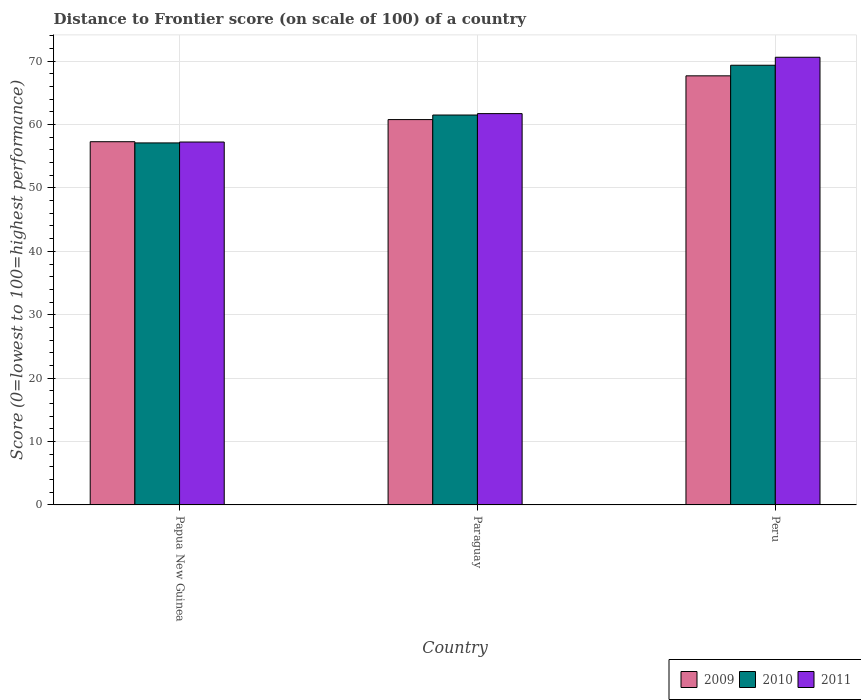Are the number of bars on each tick of the X-axis equal?
Provide a succinct answer. Yes. How many bars are there on the 2nd tick from the left?
Offer a very short reply. 3. What is the label of the 3rd group of bars from the left?
Your answer should be very brief. Peru. What is the distance to frontier score of in 2011 in Paraguay?
Give a very brief answer. 61.72. Across all countries, what is the maximum distance to frontier score of in 2009?
Make the answer very short. 67.68. Across all countries, what is the minimum distance to frontier score of in 2010?
Offer a very short reply. 57.1. In which country was the distance to frontier score of in 2010 maximum?
Your response must be concise. Peru. In which country was the distance to frontier score of in 2009 minimum?
Give a very brief answer. Papua New Guinea. What is the total distance to frontier score of in 2009 in the graph?
Your answer should be very brief. 185.75. What is the difference between the distance to frontier score of in 2010 in Papua New Guinea and that in Paraguay?
Keep it short and to the point. -4.4. What is the difference between the distance to frontier score of in 2011 in Papua New Guinea and the distance to frontier score of in 2009 in Paraguay?
Give a very brief answer. -3.54. What is the average distance to frontier score of in 2010 per country?
Your answer should be very brief. 62.65. What is the difference between the distance to frontier score of of/in 2011 and distance to frontier score of of/in 2010 in Peru?
Give a very brief answer. 1.26. In how many countries, is the distance to frontier score of in 2009 greater than 14?
Your answer should be very brief. 3. What is the ratio of the distance to frontier score of in 2011 in Papua New Guinea to that in Peru?
Make the answer very short. 0.81. Is the distance to frontier score of in 2009 in Papua New Guinea less than that in Paraguay?
Your response must be concise. Yes. What is the difference between the highest and the second highest distance to frontier score of in 2010?
Give a very brief answer. -4.4. What is the difference between the highest and the lowest distance to frontier score of in 2011?
Make the answer very short. 13.37. In how many countries, is the distance to frontier score of in 2009 greater than the average distance to frontier score of in 2009 taken over all countries?
Offer a terse response. 1. Is the sum of the distance to frontier score of in 2010 in Papua New Guinea and Peru greater than the maximum distance to frontier score of in 2009 across all countries?
Your answer should be compact. Yes. What does the 2nd bar from the left in Papua New Guinea represents?
Keep it short and to the point. 2010. What does the 2nd bar from the right in Peru represents?
Keep it short and to the point. 2010. How many countries are there in the graph?
Provide a short and direct response. 3. Are the values on the major ticks of Y-axis written in scientific E-notation?
Make the answer very short. No. Does the graph contain grids?
Your response must be concise. Yes. Where does the legend appear in the graph?
Provide a succinct answer. Bottom right. How many legend labels are there?
Offer a terse response. 3. How are the legend labels stacked?
Your answer should be very brief. Horizontal. What is the title of the graph?
Your answer should be very brief. Distance to Frontier score (on scale of 100) of a country. Does "2009" appear as one of the legend labels in the graph?
Your response must be concise. Yes. What is the label or title of the Y-axis?
Provide a succinct answer. Score (0=lowest to 100=highest performance). What is the Score (0=lowest to 100=highest performance) of 2009 in Papua New Guinea?
Provide a succinct answer. 57.29. What is the Score (0=lowest to 100=highest performance) in 2010 in Papua New Guinea?
Provide a succinct answer. 57.1. What is the Score (0=lowest to 100=highest performance) of 2011 in Papua New Guinea?
Your answer should be very brief. 57.24. What is the Score (0=lowest to 100=highest performance) in 2009 in Paraguay?
Your answer should be compact. 60.78. What is the Score (0=lowest to 100=highest performance) of 2010 in Paraguay?
Your response must be concise. 61.5. What is the Score (0=lowest to 100=highest performance) of 2011 in Paraguay?
Give a very brief answer. 61.72. What is the Score (0=lowest to 100=highest performance) in 2009 in Peru?
Your answer should be very brief. 67.68. What is the Score (0=lowest to 100=highest performance) in 2010 in Peru?
Give a very brief answer. 69.35. What is the Score (0=lowest to 100=highest performance) of 2011 in Peru?
Offer a very short reply. 70.61. Across all countries, what is the maximum Score (0=lowest to 100=highest performance) in 2009?
Provide a short and direct response. 67.68. Across all countries, what is the maximum Score (0=lowest to 100=highest performance) of 2010?
Your answer should be very brief. 69.35. Across all countries, what is the maximum Score (0=lowest to 100=highest performance) in 2011?
Keep it short and to the point. 70.61. Across all countries, what is the minimum Score (0=lowest to 100=highest performance) of 2009?
Your response must be concise. 57.29. Across all countries, what is the minimum Score (0=lowest to 100=highest performance) in 2010?
Provide a succinct answer. 57.1. Across all countries, what is the minimum Score (0=lowest to 100=highest performance) in 2011?
Offer a very short reply. 57.24. What is the total Score (0=lowest to 100=highest performance) of 2009 in the graph?
Offer a very short reply. 185.75. What is the total Score (0=lowest to 100=highest performance) in 2010 in the graph?
Keep it short and to the point. 187.95. What is the total Score (0=lowest to 100=highest performance) in 2011 in the graph?
Make the answer very short. 189.57. What is the difference between the Score (0=lowest to 100=highest performance) in 2009 in Papua New Guinea and that in Paraguay?
Provide a succinct answer. -3.49. What is the difference between the Score (0=lowest to 100=highest performance) in 2010 in Papua New Guinea and that in Paraguay?
Provide a short and direct response. -4.4. What is the difference between the Score (0=lowest to 100=highest performance) in 2011 in Papua New Guinea and that in Paraguay?
Your answer should be compact. -4.48. What is the difference between the Score (0=lowest to 100=highest performance) in 2009 in Papua New Guinea and that in Peru?
Give a very brief answer. -10.39. What is the difference between the Score (0=lowest to 100=highest performance) in 2010 in Papua New Guinea and that in Peru?
Make the answer very short. -12.25. What is the difference between the Score (0=lowest to 100=highest performance) of 2011 in Papua New Guinea and that in Peru?
Ensure brevity in your answer.  -13.37. What is the difference between the Score (0=lowest to 100=highest performance) of 2010 in Paraguay and that in Peru?
Your answer should be very brief. -7.85. What is the difference between the Score (0=lowest to 100=highest performance) in 2011 in Paraguay and that in Peru?
Offer a terse response. -8.89. What is the difference between the Score (0=lowest to 100=highest performance) of 2009 in Papua New Guinea and the Score (0=lowest to 100=highest performance) of 2010 in Paraguay?
Provide a short and direct response. -4.21. What is the difference between the Score (0=lowest to 100=highest performance) of 2009 in Papua New Guinea and the Score (0=lowest to 100=highest performance) of 2011 in Paraguay?
Provide a short and direct response. -4.43. What is the difference between the Score (0=lowest to 100=highest performance) in 2010 in Papua New Guinea and the Score (0=lowest to 100=highest performance) in 2011 in Paraguay?
Your answer should be very brief. -4.62. What is the difference between the Score (0=lowest to 100=highest performance) in 2009 in Papua New Guinea and the Score (0=lowest to 100=highest performance) in 2010 in Peru?
Offer a terse response. -12.06. What is the difference between the Score (0=lowest to 100=highest performance) in 2009 in Papua New Guinea and the Score (0=lowest to 100=highest performance) in 2011 in Peru?
Your response must be concise. -13.32. What is the difference between the Score (0=lowest to 100=highest performance) in 2010 in Papua New Guinea and the Score (0=lowest to 100=highest performance) in 2011 in Peru?
Your answer should be compact. -13.51. What is the difference between the Score (0=lowest to 100=highest performance) in 2009 in Paraguay and the Score (0=lowest to 100=highest performance) in 2010 in Peru?
Offer a very short reply. -8.57. What is the difference between the Score (0=lowest to 100=highest performance) of 2009 in Paraguay and the Score (0=lowest to 100=highest performance) of 2011 in Peru?
Your response must be concise. -9.83. What is the difference between the Score (0=lowest to 100=highest performance) of 2010 in Paraguay and the Score (0=lowest to 100=highest performance) of 2011 in Peru?
Offer a very short reply. -9.11. What is the average Score (0=lowest to 100=highest performance) of 2009 per country?
Provide a succinct answer. 61.92. What is the average Score (0=lowest to 100=highest performance) of 2010 per country?
Give a very brief answer. 62.65. What is the average Score (0=lowest to 100=highest performance) in 2011 per country?
Give a very brief answer. 63.19. What is the difference between the Score (0=lowest to 100=highest performance) of 2009 and Score (0=lowest to 100=highest performance) of 2010 in Papua New Guinea?
Give a very brief answer. 0.19. What is the difference between the Score (0=lowest to 100=highest performance) of 2009 and Score (0=lowest to 100=highest performance) of 2011 in Papua New Guinea?
Provide a succinct answer. 0.05. What is the difference between the Score (0=lowest to 100=highest performance) of 2010 and Score (0=lowest to 100=highest performance) of 2011 in Papua New Guinea?
Offer a very short reply. -0.14. What is the difference between the Score (0=lowest to 100=highest performance) of 2009 and Score (0=lowest to 100=highest performance) of 2010 in Paraguay?
Your answer should be very brief. -0.72. What is the difference between the Score (0=lowest to 100=highest performance) in 2009 and Score (0=lowest to 100=highest performance) in 2011 in Paraguay?
Ensure brevity in your answer.  -0.94. What is the difference between the Score (0=lowest to 100=highest performance) of 2010 and Score (0=lowest to 100=highest performance) of 2011 in Paraguay?
Offer a terse response. -0.22. What is the difference between the Score (0=lowest to 100=highest performance) of 2009 and Score (0=lowest to 100=highest performance) of 2010 in Peru?
Give a very brief answer. -1.67. What is the difference between the Score (0=lowest to 100=highest performance) in 2009 and Score (0=lowest to 100=highest performance) in 2011 in Peru?
Your response must be concise. -2.93. What is the difference between the Score (0=lowest to 100=highest performance) in 2010 and Score (0=lowest to 100=highest performance) in 2011 in Peru?
Provide a short and direct response. -1.26. What is the ratio of the Score (0=lowest to 100=highest performance) in 2009 in Papua New Guinea to that in Paraguay?
Offer a terse response. 0.94. What is the ratio of the Score (0=lowest to 100=highest performance) of 2010 in Papua New Guinea to that in Paraguay?
Your answer should be very brief. 0.93. What is the ratio of the Score (0=lowest to 100=highest performance) in 2011 in Papua New Guinea to that in Paraguay?
Keep it short and to the point. 0.93. What is the ratio of the Score (0=lowest to 100=highest performance) of 2009 in Papua New Guinea to that in Peru?
Offer a terse response. 0.85. What is the ratio of the Score (0=lowest to 100=highest performance) of 2010 in Papua New Guinea to that in Peru?
Ensure brevity in your answer.  0.82. What is the ratio of the Score (0=lowest to 100=highest performance) in 2011 in Papua New Guinea to that in Peru?
Keep it short and to the point. 0.81. What is the ratio of the Score (0=lowest to 100=highest performance) of 2009 in Paraguay to that in Peru?
Your answer should be very brief. 0.9. What is the ratio of the Score (0=lowest to 100=highest performance) of 2010 in Paraguay to that in Peru?
Offer a very short reply. 0.89. What is the ratio of the Score (0=lowest to 100=highest performance) of 2011 in Paraguay to that in Peru?
Your answer should be compact. 0.87. What is the difference between the highest and the second highest Score (0=lowest to 100=highest performance) of 2009?
Give a very brief answer. 6.9. What is the difference between the highest and the second highest Score (0=lowest to 100=highest performance) in 2010?
Give a very brief answer. 7.85. What is the difference between the highest and the second highest Score (0=lowest to 100=highest performance) in 2011?
Ensure brevity in your answer.  8.89. What is the difference between the highest and the lowest Score (0=lowest to 100=highest performance) in 2009?
Offer a terse response. 10.39. What is the difference between the highest and the lowest Score (0=lowest to 100=highest performance) of 2010?
Your answer should be very brief. 12.25. What is the difference between the highest and the lowest Score (0=lowest to 100=highest performance) of 2011?
Keep it short and to the point. 13.37. 